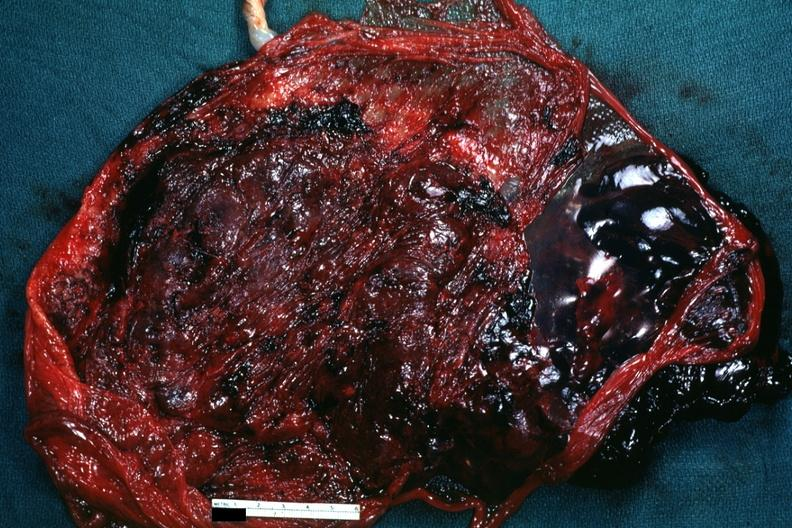what is present?
Answer the question using a single word or phrase. Abruption 